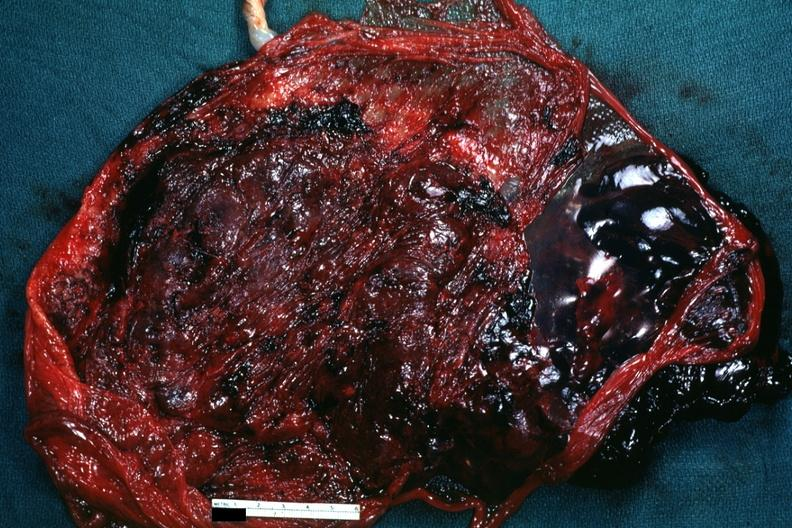what is present?
Answer the question using a single word or phrase. Abruption 